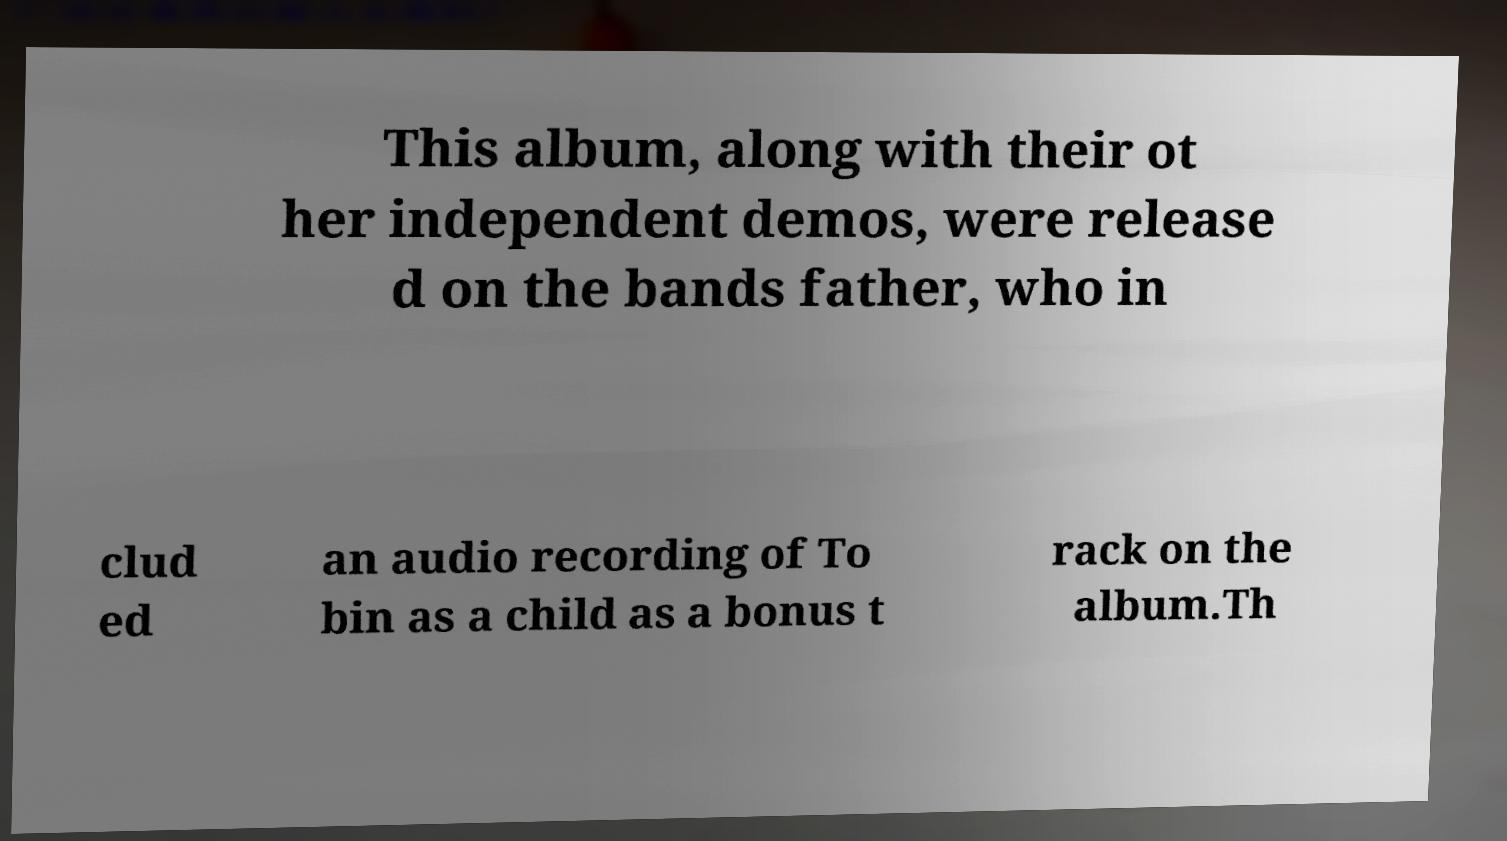Can you accurately transcribe the text from the provided image for me? This album, along with their ot her independent demos, were release d on the bands father, who in clud ed an audio recording of To bin as a child as a bonus t rack on the album.Th 